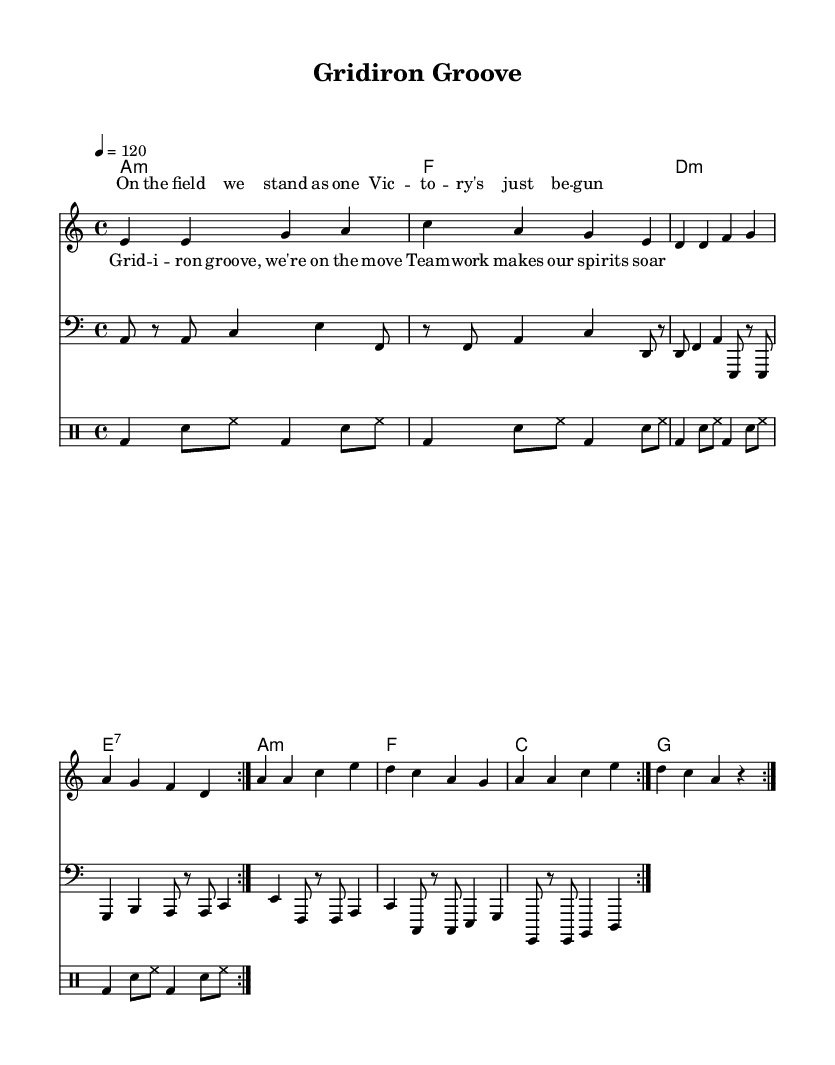What is the key signature of this music? The key signature is indicated by the presence of no sharps or flats at the beginning of the staff, which implies it is in A minor.
Answer: A minor What is the time signature of this music? The time signature is indicated at the beginning of the staff; it shows a "4" over a "4," meaning there are four beats per measure, and a quarter note receives one beat.
Answer: 4/4 What is the tempo marking of this music? The tempo is marked at the beginning of the score, indicated by "4=120," which means there are 120 quarter note beats per minute.
Answer: 120 How many times does the verse repeat? The repeat structure indicated by "volta 2" means that the melody and lyrics should be played twice, as instructed in the repeat notation.
Answer: 2 Identify the style of this music piece. The use of syncopated rhythms, a steady four-on-the-floor beat from the drum pattern, and the upbeat lyrics about teamwork suggest it fits the disco genre.
Answer: Disco Which instrument plays the bass line? The clef at the beginning of the staff labeled "bass" indicates that this part is written for a bass instrument, specifically for bass clef notation.
Answer: Bass What is the main theme of the lyrics in this piece? The lyrics discuss themes of unity and teamwork in sports, with phrases suggesting collective movement and spirit, indicative of athletic achievement.
Answer: Teamwork 